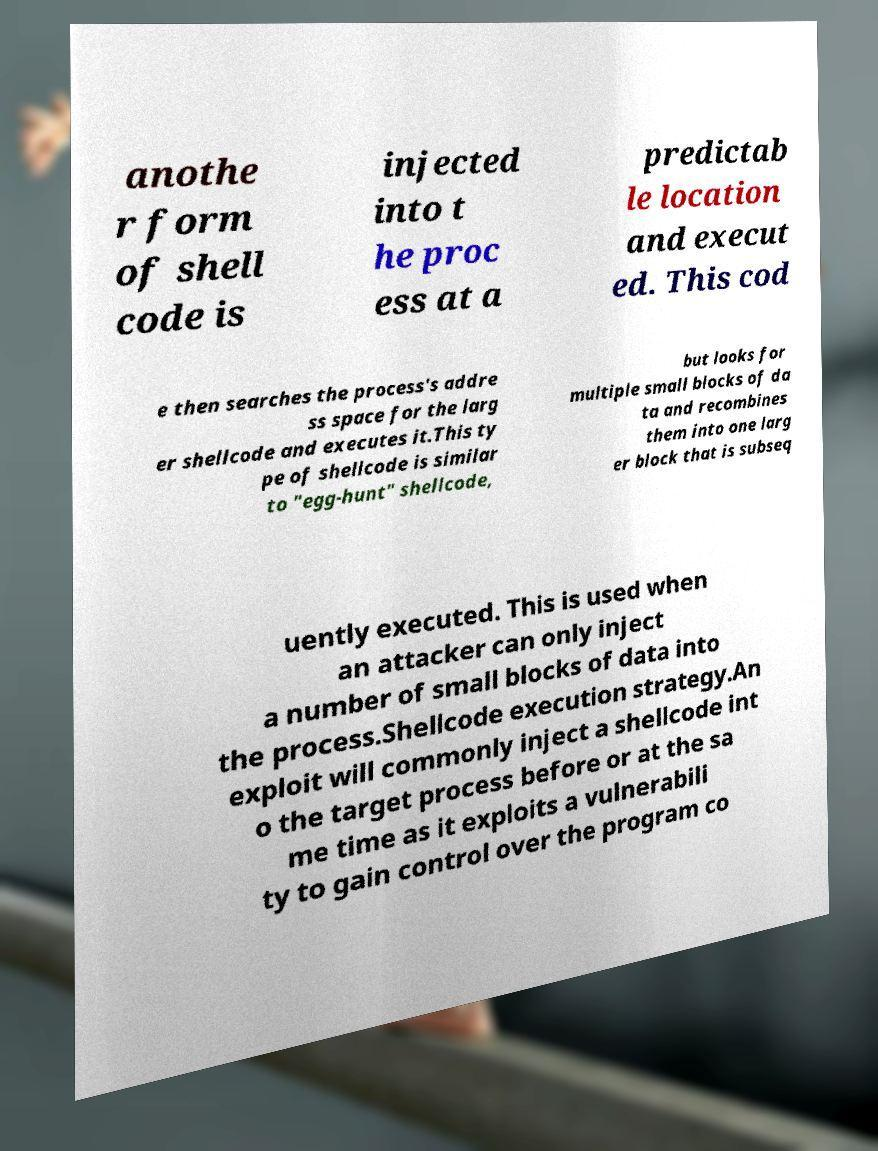For documentation purposes, I need the text within this image transcribed. Could you provide that? anothe r form of shell code is injected into t he proc ess at a predictab le location and execut ed. This cod e then searches the process's addre ss space for the larg er shellcode and executes it.This ty pe of shellcode is similar to "egg-hunt" shellcode, but looks for multiple small blocks of da ta and recombines them into one larg er block that is subseq uently executed. This is used when an attacker can only inject a number of small blocks of data into the process.Shellcode execution strategy.An exploit will commonly inject a shellcode int o the target process before or at the sa me time as it exploits a vulnerabili ty to gain control over the program co 